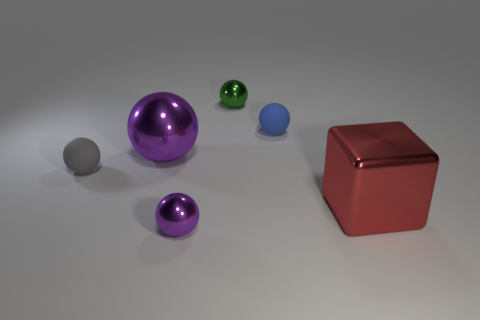Are there any tiny metal spheres of the same color as the large metal ball?
Offer a terse response. Yes. The small thing that is the same color as the large sphere is what shape?
Ensure brevity in your answer.  Sphere. How many cylinders are cyan shiny objects or tiny blue objects?
Ensure brevity in your answer.  0. There is a large purple thing that is the same shape as the tiny green metal thing; what is its material?
Keep it short and to the point. Metal. There is a red thing that is the same material as the big purple thing; what is its size?
Offer a terse response. Large. There is a rubber thing that is to the right of the small purple metallic ball; does it have the same shape as the large thing in front of the large purple sphere?
Your response must be concise. No. The big cube that is the same material as the small purple thing is what color?
Keep it short and to the point. Red. Does the purple metal ball behind the red thing have the same size as the shiny thing to the right of the small blue sphere?
Make the answer very short. Yes. What is the shape of the tiny object that is in front of the small blue matte object and right of the gray rubber sphere?
Offer a terse response. Sphere. Are there any big blue cylinders that have the same material as the big purple object?
Your answer should be compact. No. 